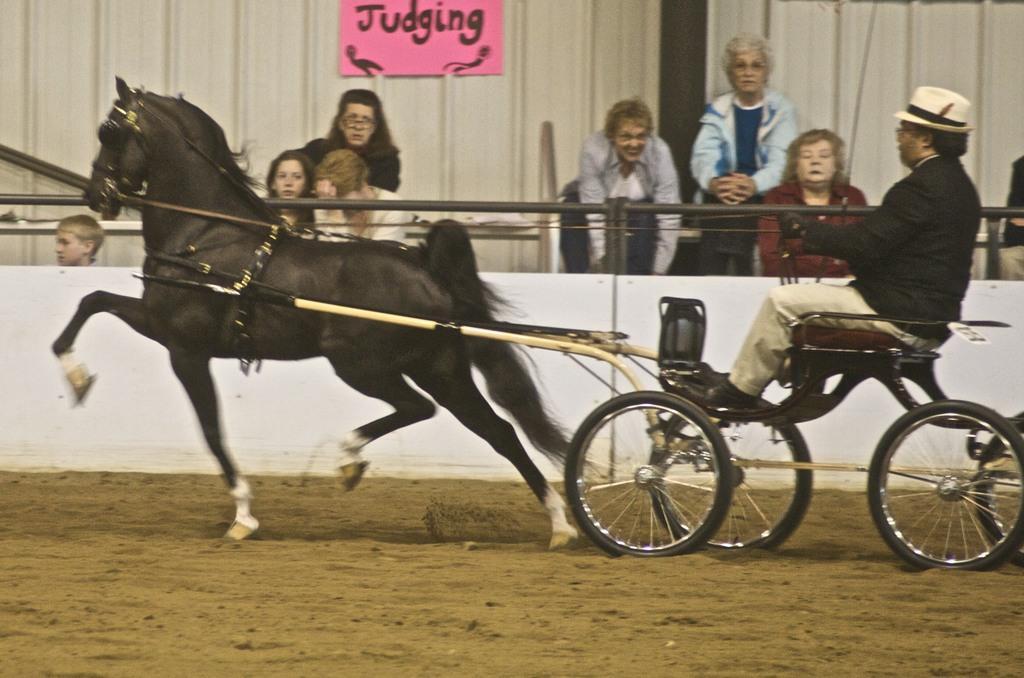How would you summarize this image in a sentence or two? In this image, we can see persons wearing clothes. There is a person on the right side of the image sitting on the horse cart. There is a board at the top of the image. 